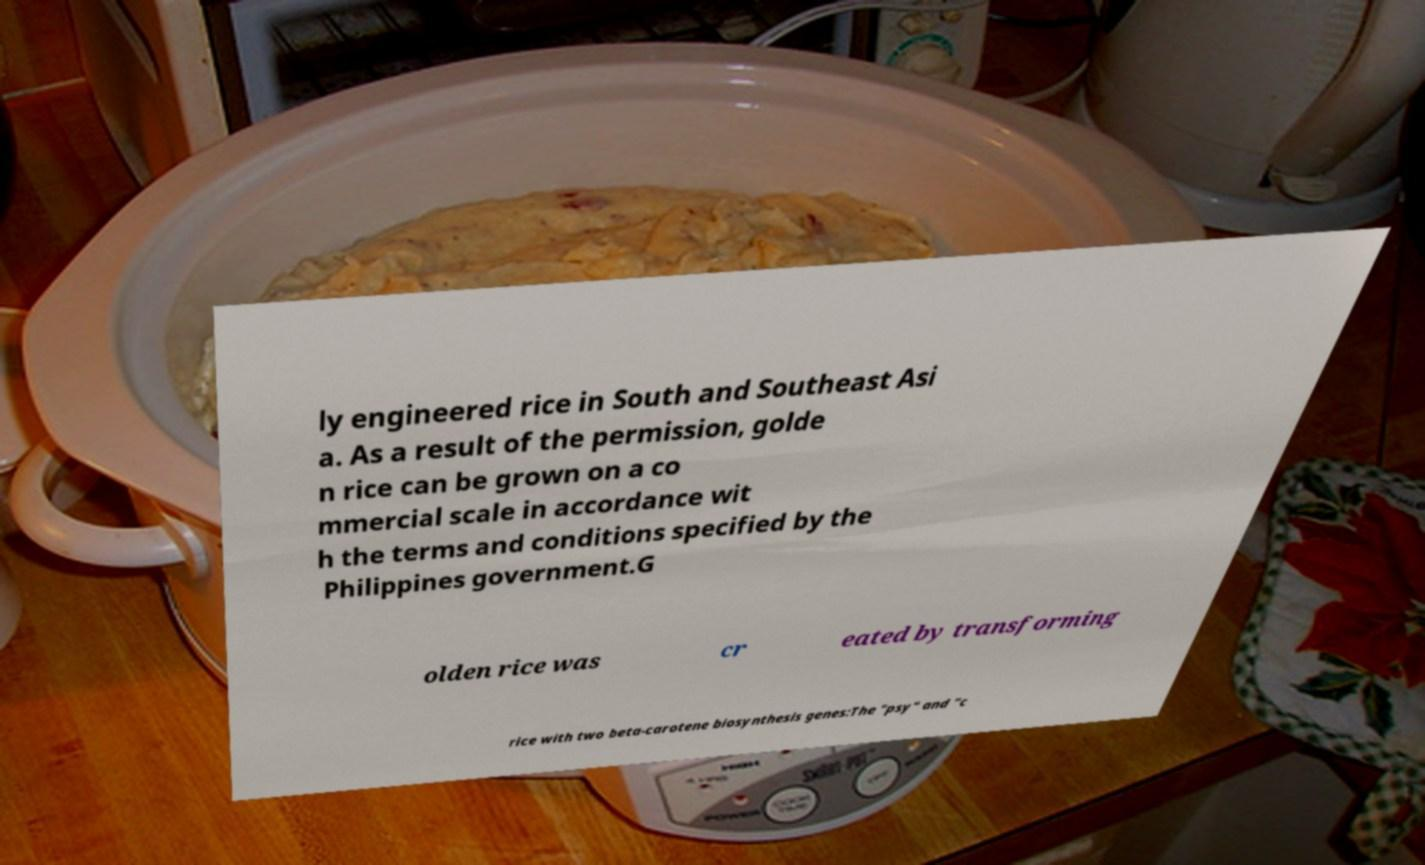What messages or text are displayed in this image? I need them in a readable, typed format. ly engineered rice in South and Southeast Asi a. As a result of the permission, golde n rice can be grown on a co mmercial scale in accordance wit h the terms and conditions specified by the Philippines government.G olden rice was cr eated by transforming rice with two beta-carotene biosynthesis genes:The "psy" and "c 